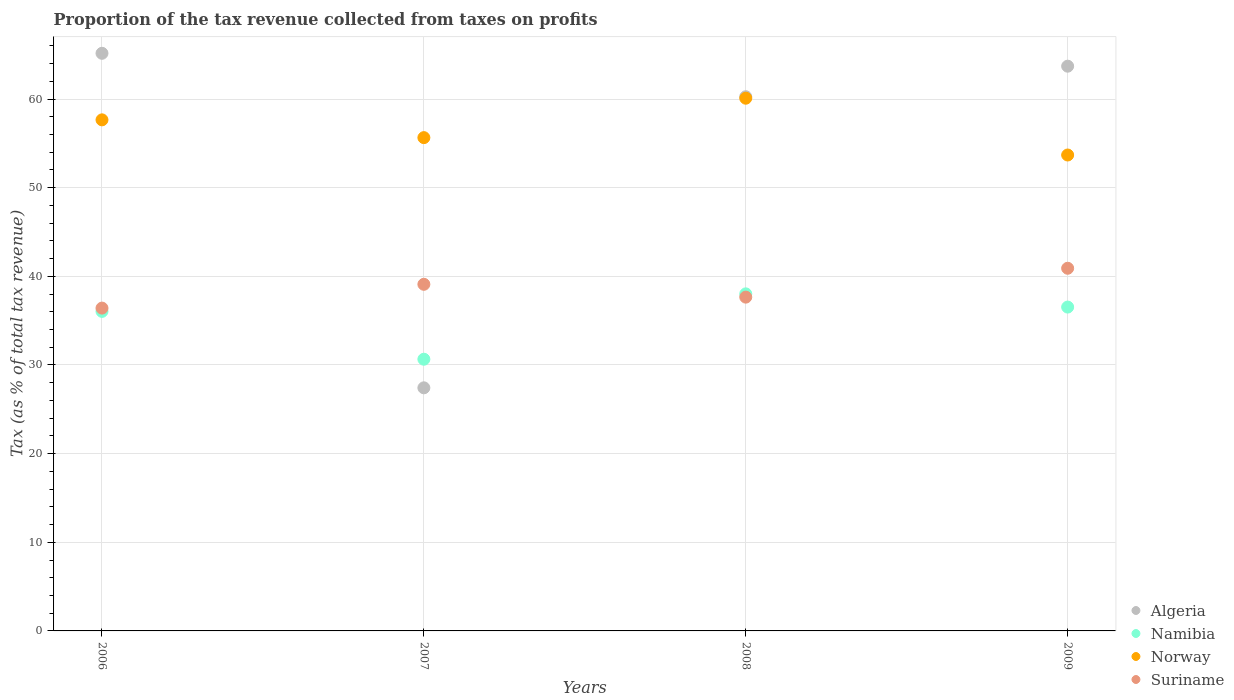What is the proportion of the tax revenue collected in Algeria in 2007?
Your answer should be compact. 27.42. Across all years, what is the maximum proportion of the tax revenue collected in Norway?
Offer a terse response. 60.09. Across all years, what is the minimum proportion of the tax revenue collected in Norway?
Your answer should be compact. 53.69. What is the total proportion of the tax revenue collected in Norway in the graph?
Provide a short and direct response. 227.08. What is the difference between the proportion of the tax revenue collected in Namibia in 2007 and that in 2009?
Your response must be concise. -5.88. What is the difference between the proportion of the tax revenue collected in Namibia in 2006 and the proportion of the tax revenue collected in Algeria in 2007?
Ensure brevity in your answer.  8.62. What is the average proportion of the tax revenue collected in Namibia per year?
Your answer should be compact. 35.31. In the year 2007, what is the difference between the proportion of the tax revenue collected in Suriname and proportion of the tax revenue collected in Algeria?
Offer a terse response. 11.68. What is the ratio of the proportion of the tax revenue collected in Norway in 2007 to that in 2009?
Your answer should be compact. 1.04. Is the proportion of the tax revenue collected in Suriname in 2006 less than that in 2009?
Provide a short and direct response. Yes. What is the difference between the highest and the second highest proportion of the tax revenue collected in Norway?
Offer a terse response. 2.44. What is the difference between the highest and the lowest proportion of the tax revenue collected in Suriname?
Your answer should be compact. 4.49. In how many years, is the proportion of the tax revenue collected in Namibia greater than the average proportion of the tax revenue collected in Namibia taken over all years?
Ensure brevity in your answer.  3. Does the proportion of the tax revenue collected in Norway monotonically increase over the years?
Your answer should be compact. No. Is the proportion of the tax revenue collected in Suriname strictly greater than the proportion of the tax revenue collected in Algeria over the years?
Provide a short and direct response. No. Is the proportion of the tax revenue collected in Algeria strictly less than the proportion of the tax revenue collected in Suriname over the years?
Keep it short and to the point. No. What is the difference between two consecutive major ticks on the Y-axis?
Provide a succinct answer. 10. Does the graph contain any zero values?
Make the answer very short. No. Where does the legend appear in the graph?
Provide a succinct answer. Bottom right. How are the legend labels stacked?
Your response must be concise. Vertical. What is the title of the graph?
Offer a very short reply. Proportion of the tax revenue collected from taxes on profits. What is the label or title of the Y-axis?
Provide a short and direct response. Tax (as % of total tax revenue). What is the Tax (as % of total tax revenue) in Algeria in 2006?
Your answer should be compact. 65.16. What is the Tax (as % of total tax revenue) in Namibia in 2006?
Provide a short and direct response. 36.05. What is the Tax (as % of total tax revenue) in Norway in 2006?
Your answer should be compact. 57.65. What is the Tax (as % of total tax revenue) of Suriname in 2006?
Your answer should be compact. 36.42. What is the Tax (as % of total tax revenue) in Algeria in 2007?
Offer a very short reply. 27.42. What is the Tax (as % of total tax revenue) in Namibia in 2007?
Offer a terse response. 30.65. What is the Tax (as % of total tax revenue) of Norway in 2007?
Make the answer very short. 55.65. What is the Tax (as % of total tax revenue) of Suriname in 2007?
Make the answer very short. 39.1. What is the Tax (as % of total tax revenue) of Algeria in 2008?
Your response must be concise. 60.26. What is the Tax (as % of total tax revenue) of Namibia in 2008?
Your answer should be very brief. 38.02. What is the Tax (as % of total tax revenue) of Norway in 2008?
Provide a short and direct response. 60.09. What is the Tax (as % of total tax revenue) in Suriname in 2008?
Give a very brief answer. 37.65. What is the Tax (as % of total tax revenue) of Algeria in 2009?
Ensure brevity in your answer.  63.71. What is the Tax (as % of total tax revenue) in Namibia in 2009?
Your response must be concise. 36.53. What is the Tax (as % of total tax revenue) of Norway in 2009?
Provide a short and direct response. 53.69. What is the Tax (as % of total tax revenue) in Suriname in 2009?
Offer a terse response. 40.91. Across all years, what is the maximum Tax (as % of total tax revenue) of Algeria?
Your response must be concise. 65.16. Across all years, what is the maximum Tax (as % of total tax revenue) in Namibia?
Your response must be concise. 38.02. Across all years, what is the maximum Tax (as % of total tax revenue) in Norway?
Your answer should be very brief. 60.09. Across all years, what is the maximum Tax (as % of total tax revenue) in Suriname?
Provide a succinct answer. 40.91. Across all years, what is the minimum Tax (as % of total tax revenue) in Algeria?
Your answer should be very brief. 27.42. Across all years, what is the minimum Tax (as % of total tax revenue) of Namibia?
Provide a short and direct response. 30.65. Across all years, what is the minimum Tax (as % of total tax revenue) of Norway?
Make the answer very short. 53.69. Across all years, what is the minimum Tax (as % of total tax revenue) of Suriname?
Provide a short and direct response. 36.42. What is the total Tax (as % of total tax revenue) in Algeria in the graph?
Your response must be concise. 216.55. What is the total Tax (as % of total tax revenue) in Namibia in the graph?
Give a very brief answer. 141.25. What is the total Tax (as % of total tax revenue) of Norway in the graph?
Ensure brevity in your answer.  227.08. What is the total Tax (as % of total tax revenue) of Suriname in the graph?
Your response must be concise. 154.08. What is the difference between the Tax (as % of total tax revenue) of Algeria in 2006 and that in 2007?
Provide a succinct answer. 37.74. What is the difference between the Tax (as % of total tax revenue) in Namibia in 2006 and that in 2007?
Offer a terse response. 5.4. What is the difference between the Tax (as % of total tax revenue) in Norway in 2006 and that in 2007?
Offer a terse response. 2.01. What is the difference between the Tax (as % of total tax revenue) of Suriname in 2006 and that in 2007?
Ensure brevity in your answer.  -2.68. What is the difference between the Tax (as % of total tax revenue) in Algeria in 2006 and that in 2008?
Give a very brief answer. 4.9. What is the difference between the Tax (as % of total tax revenue) of Namibia in 2006 and that in 2008?
Keep it short and to the point. -1.98. What is the difference between the Tax (as % of total tax revenue) of Norway in 2006 and that in 2008?
Your response must be concise. -2.44. What is the difference between the Tax (as % of total tax revenue) in Suriname in 2006 and that in 2008?
Offer a terse response. -1.24. What is the difference between the Tax (as % of total tax revenue) in Algeria in 2006 and that in 2009?
Offer a very short reply. 1.45. What is the difference between the Tax (as % of total tax revenue) of Namibia in 2006 and that in 2009?
Your answer should be very brief. -0.49. What is the difference between the Tax (as % of total tax revenue) of Norway in 2006 and that in 2009?
Offer a terse response. 3.97. What is the difference between the Tax (as % of total tax revenue) in Suriname in 2006 and that in 2009?
Offer a very short reply. -4.49. What is the difference between the Tax (as % of total tax revenue) in Algeria in 2007 and that in 2008?
Your answer should be compact. -32.84. What is the difference between the Tax (as % of total tax revenue) in Namibia in 2007 and that in 2008?
Keep it short and to the point. -7.37. What is the difference between the Tax (as % of total tax revenue) in Norway in 2007 and that in 2008?
Make the answer very short. -4.45. What is the difference between the Tax (as % of total tax revenue) of Suriname in 2007 and that in 2008?
Your answer should be compact. 1.45. What is the difference between the Tax (as % of total tax revenue) in Algeria in 2007 and that in 2009?
Keep it short and to the point. -36.28. What is the difference between the Tax (as % of total tax revenue) of Namibia in 2007 and that in 2009?
Keep it short and to the point. -5.88. What is the difference between the Tax (as % of total tax revenue) of Norway in 2007 and that in 2009?
Offer a very short reply. 1.96. What is the difference between the Tax (as % of total tax revenue) in Suriname in 2007 and that in 2009?
Keep it short and to the point. -1.81. What is the difference between the Tax (as % of total tax revenue) of Algeria in 2008 and that in 2009?
Provide a succinct answer. -3.45. What is the difference between the Tax (as % of total tax revenue) in Namibia in 2008 and that in 2009?
Your answer should be compact. 1.49. What is the difference between the Tax (as % of total tax revenue) of Norway in 2008 and that in 2009?
Make the answer very short. 6.41. What is the difference between the Tax (as % of total tax revenue) of Suriname in 2008 and that in 2009?
Provide a succinct answer. -3.26. What is the difference between the Tax (as % of total tax revenue) of Algeria in 2006 and the Tax (as % of total tax revenue) of Namibia in 2007?
Provide a short and direct response. 34.51. What is the difference between the Tax (as % of total tax revenue) of Algeria in 2006 and the Tax (as % of total tax revenue) of Norway in 2007?
Ensure brevity in your answer.  9.51. What is the difference between the Tax (as % of total tax revenue) of Algeria in 2006 and the Tax (as % of total tax revenue) of Suriname in 2007?
Give a very brief answer. 26.06. What is the difference between the Tax (as % of total tax revenue) of Namibia in 2006 and the Tax (as % of total tax revenue) of Norway in 2007?
Ensure brevity in your answer.  -19.6. What is the difference between the Tax (as % of total tax revenue) of Namibia in 2006 and the Tax (as % of total tax revenue) of Suriname in 2007?
Your answer should be very brief. -3.05. What is the difference between the Tax (as % of total tax revenue) of Norway in 2006 and the Tax (as % of total tax revenue) of Suriname in 2007?
Make the answer very short. 18.55. What is the difference between the Tax (as % of total tax revenue) of Algeria in 2006 and the Tax (as % of total tax revenue) of Namibia in 2008?
Ensure brevity in your answer.  27.14. What is the difference between the Tax (as % of total tax revenue) in Algeria in 2006 and the Tax (as % of total tax revenue) in Norway in 2008?
Make the answer very short. 5.07. What is the difference between the Tax (as % of total tax revenue) in Algeria in 2006 and the Tax (as % of total tax revenue) in Suriname in 2008?
Your response must be concise. 27.51. What is the difference between the Tax (as % of total tax revenue) in Namibia in 2006 and the Tax (as % of total tax revenue) in Norway in 2008?
Keep it short and to the point. -24.05. What is the difference between the Tax (as % of total tax revenue) in Namibia in 2006 and the Tax (as % of total tax revenue) in Suriname in 2008?
Offer a terse response. -1.61. What is the difference between the Tax (as % of total tax revenue) of Norway in 2006 and the Tax (as % of total tax revenue) of Suriname in 2008?
Give a very brief answer. 20. What is the difference between the Tax (as % of total tax revenue) in Algeria in 2006 and the Tax (as % of total tax revenue) in Namibia in 2009?
Ensure brevity in your answer.  28.63. What is the difference between the Tax (as % of total tax revenue) of Algeria in 2006 and the Tax (as % of total tax revenue) of Norway in 2009?
Make the answer very short. 11.47. What is the difference between the Tax (as % of total tax revenue) of Algeria in 2006 and the Tax (as % of total tax revenue) of Suriname in 2009?
Offer a terse response. 24.25. What is the difference between the Tax (as % of total tax revenue) in Namibia in 2006 and the Tax (as % of total tax revenue) in Norway in 2009?
Offer a terse response. -17.64. What is the difference between the Tax (as % of total tax revenue) of Namibia in 2006 and the Tax (as % of total tax revenue) of Suriname in 2009?
Your response must be concise. -4.86. What is the difference between the Tax (as % of total tax revenue) of Norway in 2006 and the Tax (as % of total tax revenue) of Suriname in 2009?
Offer a terse response. 16.74. What is the difference between the Tax (as % of total tax revenue) of Algeria in 2007 and the Tax (as % of total tax revenue) of Namibia in 2008?
Make the answer very short. -10.6. What is the difference between the Tax (as % of total tax revenue) in Algeria in 2007 and the Tax (as % of total tax revenue) in Norway in 2008?
Give a very brief answer. -32.67. What is the difference between the Tax (as % of total tax revenue) of Algeria in 2007 and the Tax (as % of total tax revenue) of Suriname in 2008?
Keep it short and to the point. -10.23. What is the difference between the Tax (as % of total tax revenue) of Namibia in 2007 and the Tax (as % of total tax revenue) of Norway in 2008?
Your answer should be very brief. -29.44. What is the difference between the Tax (as % of total tax revenue) in Namibia in 2007 and the Tax (as % of total tax revenue) in Suriname in 2008?
Your answer should be compact. -7. What is the difference between the Tax (as % of total tax revenue) of Norway in 2007 and the Tax (as % of total tax revenue) of Suriname in 2008?
Your response must be concise. 17.99. What is the difference between the Tax (as % of total tax revenue) of Algeria in 2007 and the Tax (as % of total tax revenue) of Namibia in 2009?
Your response must be concise. -9.11. What is the difference between the Tax (as % of total tax revenue) in Algeria in 2007 and the Tax (as % of total tax revenue) in Norway in 2009?
Your answer should be very brief. -26.26. What is the difference between the Tax (as % of total tax revenue) in Algeria in 2007 and the Tax (as % of total tax revenue) in Suriname in 2009?
Ensure brevity in your answer.  -13.49. What is the difference between the Tax (as % of total tax revenue) in Namibia in 2007 and the Tax (as % of total tax revenue) in Norway in 2009?
Your answer should be compact. -23.04. What is the difference between the Tax (as % of total tax revenue) in Namibia in 2007 and the Tax (as % of total tax revenue) in Suriname in 2009?
Keep it short and to the point. -10.26. What is the difference between the Tax (as % of total tax revenue) of Norway in 2007 and the Tax (as % of total tax revenue) of Suriname in 2009?
Make the answer very short. 14.74. What is the difference between the Tax (as % of total tax revenue) in Algeria in 2008 and the Tax (as % of total tax revenue) in Namibia in 2009?
Keep it short and to the point. 23.73. What is the difference between the Tax (as % of total tax revenue) in Algeria in 2008 and the Tax (as % of total tax revenue) in Norway in 2009?
Your answer should be very brief. 6.57. What is the difference between the Tax (as % of total tax revenue) in Algeria in 2008 and the Tax (as % of total tax revenue) in Suriname in 2009?
Make the answer very short. 19.35. What is the difference between the Tax (as % of total tax revenue) of Namibia in 2008 and the Tax (as % of total tax revenue) of Norway in 2009?
Make the answer very short. -15.66. What is the difference between the Tax (as % of total tax revenue) in Namibia in 2008 and the Tax (as % of total tax revenue) in Suriname in 2009?
Offer a terse response. -2.89. What is the difference between the Tax (as % of total tax revenue) in Norway in 2008 and the Tax (as % of total tax revenue) in Suriname in 2009?
Keep it short and to the point. 19.18. What is the average Tax (as % of total tax revenue) in Algeria per year?
Offer a very short reply. 54.14. What is the average Tax (as % of total tax revenue) of Namibia per year?
Provide a succinct answer. 35.31. What is the average Tax (as % of total tax revenue) of Norway per year?
Ensure brevity in your answer.  56.77. What is the average Tax (as % of total tax revenue) in Suriname per year?
Keep it short and to the point. 38.52. In the year 2006, what is the difference between the Tax (as % of total tax revenue) in Algeria and Tax (as % of total tax revenue) in Namibia?
Your answer should be very brief. 29.11. In the year 2006, what is the difference between the Tax (as % of total tax revenue) of Algeria and Tax (as % of total tax revenue) of Norway?
Your answer should be very brief. 7.51. In the year 2006, what is the difference between the Tax (as % of total tax revenue) in Algeria and Tax (as % of total tax revenue) in Suriname?
Give a very brief answer. 28.74. In the year 2006, what is the difference between the Tax (as % of total tax revenue) in Namibia and Tax (as % of total tax revenue) in Norway?
Give a very brief answer. -21.61. In the year 2006, what is the difference between the Tax (as % of total tax revenue) in Namibia and Tax (as % of total tax revenue) in Suriname?
Your answer should be compact. -0.37. In the year 2006, what is the difference between the Tax (as % of total tax revenue) of Norway and Tax (as % of total tax revenue) of Suriname?
Keep it short and to the point. 21.24. In the year 2007, what is the difference between the Tax (as % of total tax revenue) of Algeria and Tax (as % of total tax revenue) of Namibia?
Provide a short and direct response. -3.23. In the year 2007, what is the difference between the Tax (as % of total tax revenue) in Algeria and Tax (as % of total tax revenue) in Norway?
Offer a terse response. -28.22. In the year 2007, what is the difference between the Tax (as % of total tax revenue) in Algeria and Tax (as % of total tax revenue) in Suriname?
Keep it short and to the point. -11.68. In the year 2007, what is the difference between the Tax (as % of total tax revenue) of Namibia and Tax (as % of total tax revenue) of Norway?
Offer a very short reply. -25. In the year 2007, what is the difference between the Tax (as % of total tax revenue) of Namibia and Tax (as % of total tax revenue) of Suriname?
Make the answer very short. -8.45. In the year 2007, what is the difference between the Tax (as % of total tax revenue) of Norway and Tax (as % of total tax revenue) of Suriname?
Give a very brief answer. 16.55. In the year 2008, what is the difference between the Tax (as % of total tax revenue) of Algeria and Tax (as % of total tax revenue) of Namibia?
Make the answer very short. 22.24. In the year 2008, what is the difference between the Tax (as % of total tax revenue) of Algeria and Tax (as % of total tax revenue) of Norway?
Your answer should be very brief. 0.17. In the year 2008, what is the difference between the Tax (as % of total tax revenue) of Algeria and Tax (as % of total tax revenue) of Suriname?
Give a very brief answer. 22.61. In the year 2008, what is the difference between the Tax (as % of total tax revenue) in Namibia and Tax (as % of total tax revenue) in Norway?
Your response must be concise. -22.07. In the year 2008, what is the difference between the Tax (as % of total tax revenue) of Namibia and Tax (as % of total tax revenue) of Suriname?
Provide a succinct answer. 0.37. In the year 2008, what is the difference between the Tax (as % of total tax revenue) of Norway and Tax (as % of total tax revenue) of Suriname?
Provide a short and direct response. 22.44. In the year 2009, what is the difference between the Tax (as % of total tax revenue) of Algeria and Tax (as % of total tax revenue) of Namibia?
Offer a terse response. 27.17. In the year 2009, what is the difference between the Tax (as % of total tax revenue) of Algeria and Tax (as % of total tax revenue) of Norway?
Your answer should be compact. 10.02. In the year 2009, what is the difference between the Tax (as % of total tax revenue) in Algeria and Tax (as % of total tax revenue) in Suriname?
Provide a succinct answer. 22.8. In the year 2009, what is the difference between the Tax (as % of total tax revenue) of Namibia and Tax (as % of total tax revenue) of Norway?
Your answer should be very brief. -17.15. In the year 2009, what is the difference between the Tax (as % of total tax revenue) of Namibia and Tax (as % of total tax revenue) of Suriname?
Ensure brevity in your answer.  -4.38. In the year 2009, what is the difference between the Tax (as % of total tax revenue) of Norway and Tax (as % of total tax revenue) of Suriname?
Offer a terse response. 12.78. What is the ratio of the Tax (as % of total tax revenue) in Algeria in 2006 to that in 2007?
Make the answer very short. 2.38. What is the ratio of the Tax (as % of total tax revenue) of Namibia in 2006 to that in 2007?
Provide a short and direct response. 1.18. What is the ratio of the Tax (as % of total tax revenue) of Norway in 2006 to that in 2007?
Your response must be concise. 1.04. What is the ratio of the Tax (as % of total tax revenue) of Suriname in 2006 to that in 2007?
Offer a very short reply. 0.93. What is the ratio of the Tax (as % of total tax revenue) in Algeria in 2006 to that in 2008?
Provide a short and direct response. 1.08. What is the ratio of the Tax (as % of total tax revenue) in Namibia in 2006 to that in 2008?
Offer a very short reply. 0.95. What is the ratio of the Tax (as % of total tax revenue) of Norway in 2006 to that in 2008?
Your answer should be very brief. 0.96. What is the ratio of the Tax (as % of total tax revenue) in Suriname in 2006 to that in 2008?
Your answer should be compact. 0.97. What is the ratio of the Tax (as % of total tax revenue) in Algeria in 2006 to that in 2009?
Provide a short and direct response. 1.02. What is the ratio of the Tax (as % of total tax revenue) in Namibia in 2006 to that in 2009?
Keep it short and to the point. 0.99. What is the ratio of the Tax (as % of total tax revenue) of Norway in 2006 to that in 2009?
Ensure brevity in your answer.  1.07. What is the ratio of the Tax (as % of total tax revenue) of Suriname in 2006 to that in 2009?
Your response must be concise. 0.89. What is the ratio of the Tax (as % of total tax revenue) in Algeria in 2007 to that in 2008?
Your answer should be very brief. 0.46. What is the ratio of the Tax (as % of total tax revenue) in Namibia in 2007 to that in 2008?
Offer a very short reply. 0.81. What is the ratio of the Tax (as % of total tax revenue) of Norway in 2007 to that in 2008?
Your answer should be compact. 0.93. What is the ratio of the Tax (as % of total tax revenue) in Suriname in 2007 to that in 2008?
Offer a very short reply. 1.04. What is the ratio of the Tax (as % of total tax revenue) in Algeria in 2007 to that in 2009?
Make the answer very short. 0.43. What is the ratio of the Tax (as % of total tax revenue) in Namibia in 2007 to that in 2009?
Keep it short and to the point. 0.84. What is the ratio of the Tax (as % of total tax revenue) of Norway in 2007 to that in 2009?
Offer a very short reply. 1.04. What is the ratio of the Tax (as % of total tax revenue) of Suriname in 2007 to that in 2009?
Make the answer very short. 0.96. What is the ratio of the Tax (as % of total tax revenue) in Algeria in 2008 to that in 2009?
Provide a short and direct response. 0.95. What is the ratio of the Tax (as % of total tax revenue) in Namibia in 2008 to that in 2009?
Your answer should be compact. 1.04. What is the ratio of the Tax (as % of total tax revenue) of Norway in 2008 to that in 2009?
Provide a short and direct response. 1.12. What is the ratio of the Tax (as % of total tax revenue) in Suriname in 2008 to that in 2009?
Your response must be concise. 0.92. What is the difference between the highest and the second highest Tax (as % of total tax revenue) in Algeria?
Your response must be concise. 1.45. What is the difference between the highest and the second highest Tax (as % of total tax revenue) in Namibia?
Make the answer very short. 1.49. What is the difference between the highest and the second highest Tax (as % of total tax revenue) in Norway?
Keep it short and to the point. 2.44. What is the difference between the highest and the second highest Tax (as % of total tax revenue) of Suriname?
Provide a short and direct response. 1.81. What is the difference between the highest and the lowest Tax (as % of total tax revenue) of Algeria?
Your answer should be very brief. 37.74. What is the difference between the highest and the lowest Tax (as % of total tax revenue) in Namibia?
Provide a short and direct response. 7.37. What is the difference between the highest and the lowest Tax (as % of total tax revenue) in Norway?
Offer a terse response. 6.41. What is the difference between the highest and the lowest Tax (as % of total tax revenue) in Suriname?
Keep it short and to the point. 4.49. 